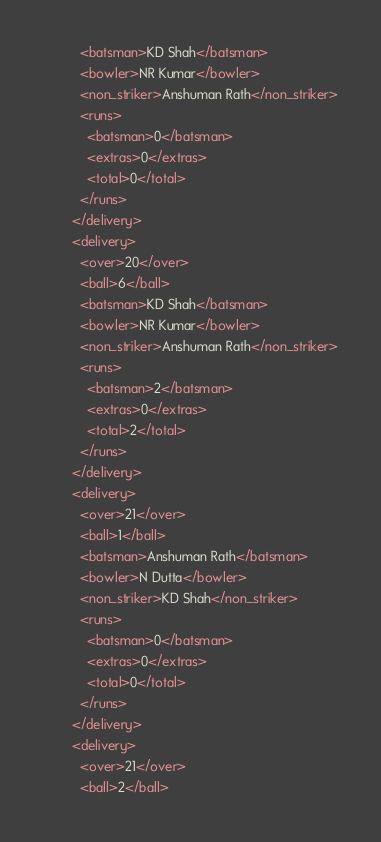<code> <loc_0><loc_0><loc_500><loc_500><_XML_>          <batsman>KD Shah</batsman>
          <bowler>NR Kumar</bowler>
          <non_striker>Anshuman Rath</non_striker>
          <runs>
            <batsman>0</batsman>
            <extras>0</extras>
            <total>0</total>
          </runs>
        </delivery>
        <delivery>
          <over>20</over>
          <ball>6</ball>
          <batsman>KD Shah</batsman>
          <bowler>NR Kumar</bowler>
          <non_striker>Anshuman Rath</non_striker>
          <runs>
            <batsman>2</batsman>
            <extras>0</extras>
            <total>2</total>
          </runs>
        </delivery>
        <delivery>
          <over>21</over>
          <ball>1</ball>
          <batsman>Anshuman Rath</batsman>
          <bowler>N Dutta</bowler>
          <non_striker>KD Shah</non_striker>
          <runs>
            <batsman>0</batsman>
            <extras>0</extras>
            <total>0</total>
          </runs>
        </delivery>
        <delivery>
          <over>21</over>
          <ball>2</ball></code> 